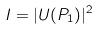Convert formula to latex. <formula><loc_0><loc_0><loc_500><loc_500>I = | U ( P _ { 1 } ) | ^ { 2 }</formula> 